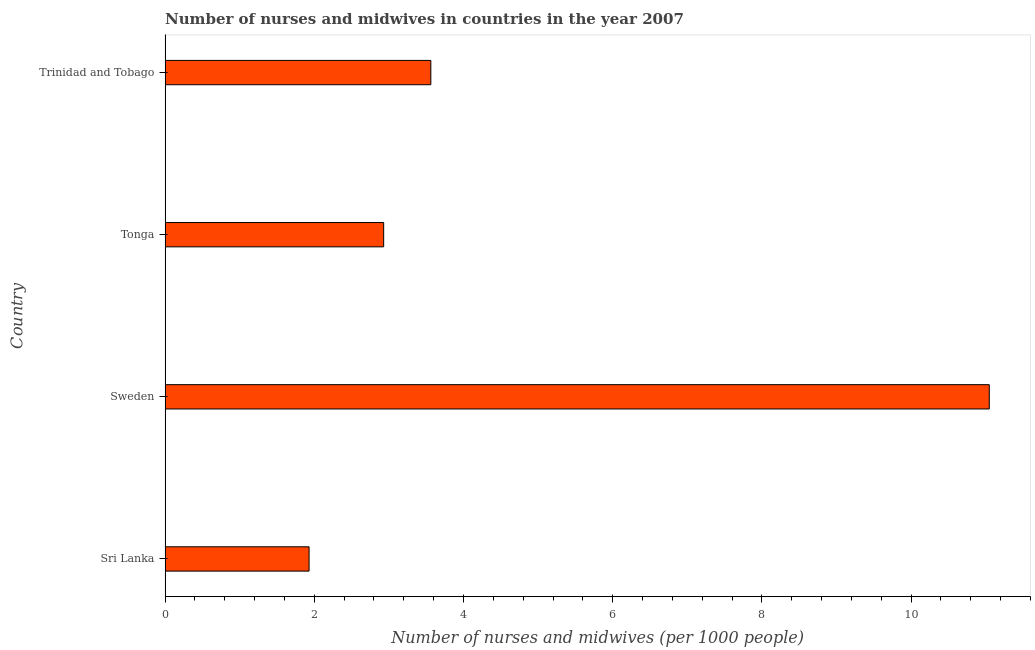Does the graph contain grids?
Provide a short and direct response. No. What is the title of the graph?
Keep it short and to the point. Number of nurses and midwives in countries in the year 2007. What is the label or title of the X-axis?
Make the answer very short. Number of nurses and midwives (per 1000 people). What is the number of nurses and midwives in Sweden?
Your response must be concise. 11.05. Across all countries, what is the maximum number of nurses and midwives?
Provide a short and direct response. 11.05. Across all countries, what is the minimum number of nurses and midwives?
Your answer should be very brief. 1.93. In which country was the number of nurses and midwives minimum?
Offer a terse response. Sri Lanka. What is the sum of the number of nurses and midwives?
Give a very brief answer. 19.47. What is the difference between the number of nurses and midwives in Tonga and Trinidad and Tobago?
Offer a very short reply. -0.63. What is the average number of nurses and midwives per country?
Offer a very short reply. 4.87. What is the median number of nurses and midwives?
Your answer should be very brief. 3.25. In how many countries, is the number of nurses and midwives greater than 10 ?
Your answer should be very brief. 1. What is the ratio of the number of nurses and midwives in Sri Lanka to that in Trinidad and Tobago?
Provide a succinct answer. 0.54. Is the number of nurses and midwives in Sri Lanka less than that in Tonga?
Offer a terse response. Yes. What is the difference between the highest and the second highest number of nurses and midwives?
Your answer should be compact. 7.49. Is the sum of the number of nurses and midwives in Sri Lanka and Trinidad and Tobago greater than the maximum number of nurses and midwives across all countries?
Offer a terse response. No. What is the difference between the highest and the lowest number of nurses and midwives?
Keep it short and to the point. 9.12. How many countries are there in the graph?
Offer a very short reply. 4. What is the Number of nurses and midwives (per 1000 people) in Sri Lanka?
Give a very brief answer. 1.93. What is the Number of nurses and midwives (per 1000 people) in Sweden?
Make the answer very short. 11.05. What is the Number of nurses and midwives (per 1000 people) of Tonga?
Provide a short and direct response. 2.93. What is the Number of nurses and midwives (per 1000 people) of Trinidad and Tobago?
Your response must be concise. 3.56. What is the difference between the Number of nurses and midwives (per 1000 people) in Sri Lanka and Sweden?
Keep it short and to the point. -9.12. What is the difference between the Number of nurses and midwives (per 1000 people) in Sri Lanka and Tonga?
Your answer should be very brief. -1. What is the difference between the Number of nurses and midwives (per 1000 people) in Sri Lanka and Trinidad and Tobago?
Offer a terse response. -1.63. What is the difference between the Number of nurses and midwives (per 1000 people) in Sweden and Tonga?
Make the answer very short. 8.12. What is the difference between the Number of nurses and midwives (per 1000 people) in Sweden and Trinidad and Tobago?
Keep it short and to the point. 7.49. What is the difference between the Number of nurses and midwives (per 1000 people) in Tonga and Trinidad and Tobago?
Give a very brief answer. -0.63. What is the ratio of the Number of nurses and midwives (per 1000 people) in Sri Lanka to that in Sweden?
Provide a short and direct response. 0.17. What is the ratio of the Number of nurses and midwives (per 1000 people) in Sri Lanka to that in Tonga?
Provide a succinct answer. 0.66. What is the ratio of the Number of nurses and midwives (per 1000 people) in Sri Lanka to that in Trinidad and Tobago?
Your answer should be compact. 0.54. What is the ratio of the Number of nurses and midwives (per 1000 people) in Sweden to that in Tonga?
Ensure brevity in your answer.  3.77. What is the ratio of the Number of nurses and midwives (per 1000 people) in Sweden to that in Trinidad and Tobago?
Provide a short and direct response. 3.1. What is the ratio of the Number of nurses and midwives (per 1000 people) in Tonga to that in Trinidad and Tobago?
Offer a terse response. 0.82. 